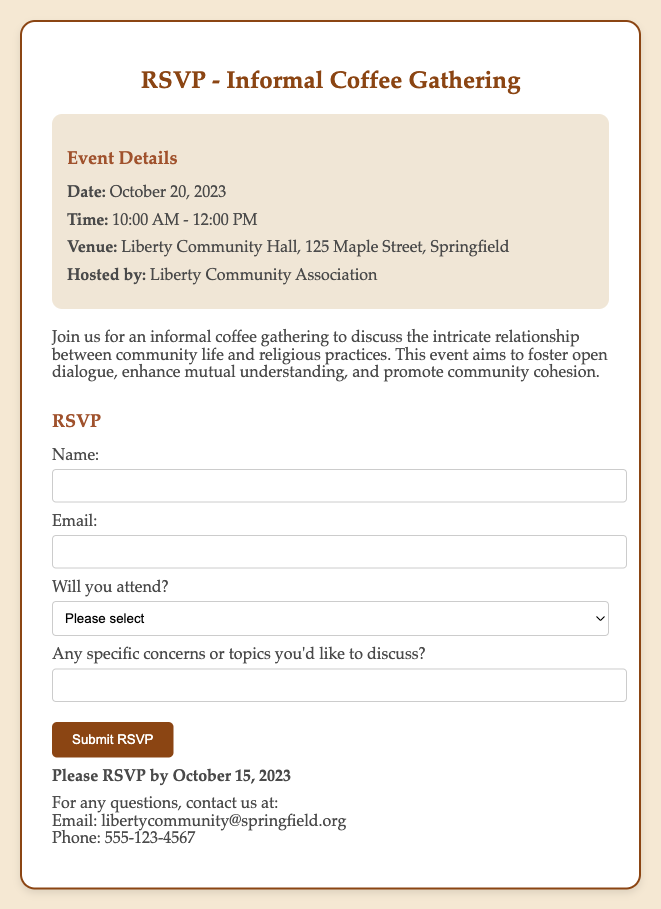What is the date of the event? The date of the event is specified as October 20, 2023 in the document.
Answer: October 20, 2023 What time does the gathering start? The gathering begins at 10:00 AM as mentioned in the event details.
Answer: 10:00 AM Where is the venue located? The venue address is provided as Liberty Community Hall, 125 Maple Street, Springfield.
Answer: Liberty Community Hall, 125 Maple Street, Springfield Who is hosting the event? The document states that the event is hosted by the Liberty Community Association.
Answer: Liberty Community Association What is the purpose of the gathering? The purpose is to foster open dialogue on community life and religious practices, as described in the document.
Answer: Foster open dialogue What is the last date to RSVP? The document specifies October 15, 2023 as the last date for RSVP submissions.
Answer: October 15, 2023 Is there a form to fill out for RSVP? Yes, the document includes an RSVP form for attendees to fill out their details.
Answer: Yes What to do if someone has questions? The document advises to contact via email or phone for any questions.
Answer: Contact via email or phone 